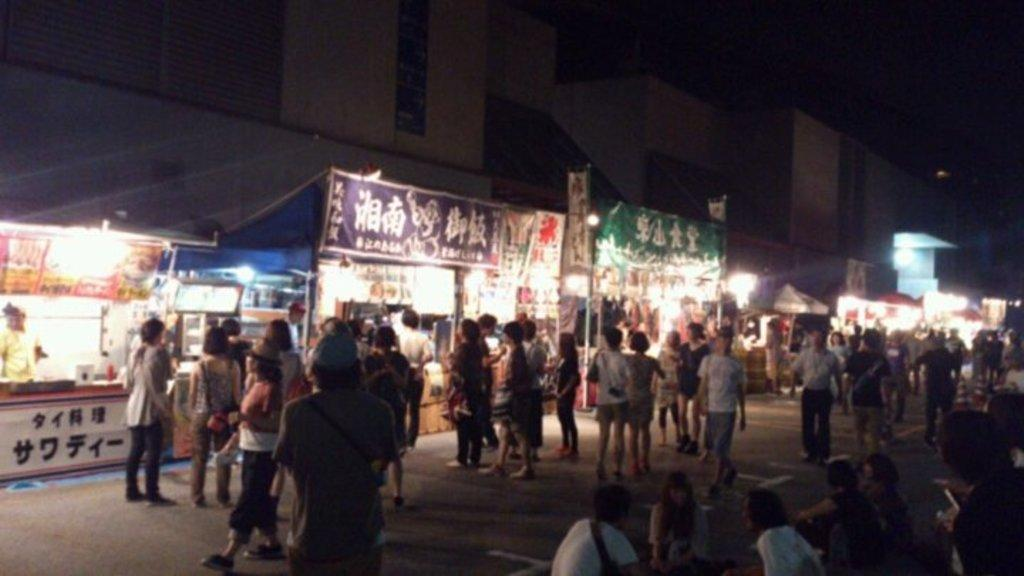How many people are in the image? There is a group of people in the image, but the exact number is not specified. What are the people in the image doing? Some people are standing, while others are walking. What can be seen in the background of the image? There are stalls, lights, and buildings visible in the background. What is the color of the sky in the image? The sky appears to be black in color. How does the hose help the people in the image? There is no hose present in the image. What type of payment is required for the people to enter the buildings in the image? There is no indication of any payment required for the people to enter the buildings in the image. 